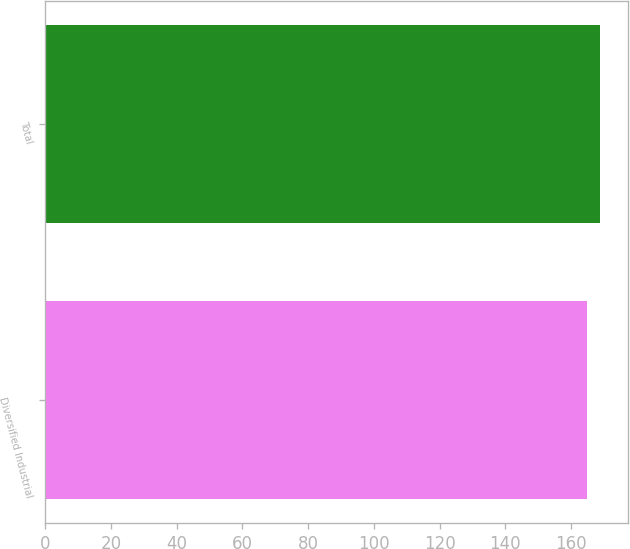Convert chart to OTSL. <chart><loc_0><loc_0><loc_500><loc_500><bar_chart><fcel>Diversified Industrial<fcel>Total<nl><fcel>165<fcel>169<nl></chart> 